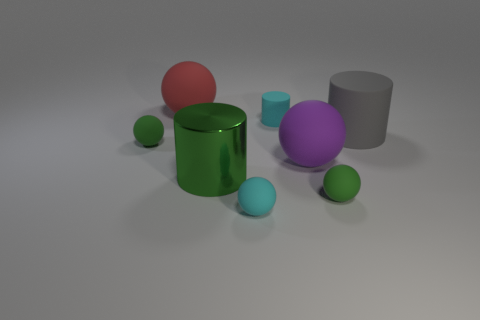Subtract all green matte balls. How many balls are left? 3 Add 1 purple matte spheres. How many objects exist? 9 Subtract 3 cylinders. How many cylinders are left? 0 Subtract all spheres. How many objects are left? 3 Subtract all green cylinders. How many cylinders are left? 2 Subtract 1 green cylinders. How many objects are left? 7 Subtract all green cylinders. Subtract all blue balls. How many cylinders are left? 2 Subtract all brown balls. How many red cylinders are left? 0 Subtract all big gray rubber cylinders. Subtract all red matte balls. How many objects are left? 6 Add 6 large shiny cylinders. How many large shiny cylinders are left? 7 